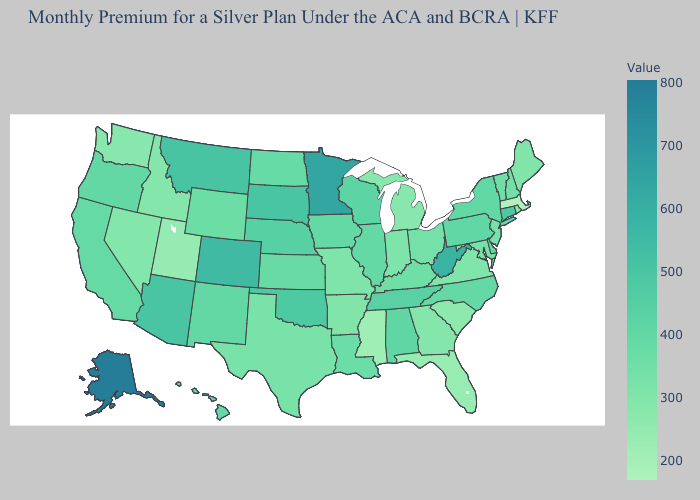Is the legend a continuous bar?
Concise answer only. Yes. Does Alaska have the highest value in the USA?
Short answer required. Yes. Does Mississippi have the highest value in the USA?
Short answer required. No. Which states have the highest value in the USA?
Keep it brief. Alaska. Does Connecticut have the lowest value in the USA?
Write a very short answer. No. Does the map have missing data?
Quick response, please. No. Which states hav the highest value in the West?
Keep it brief. Alaska. 